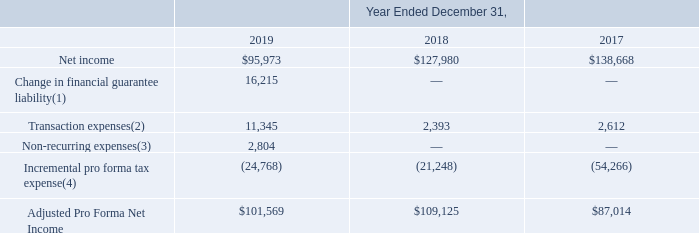ITEM 7. MANAGEMENT'S DISCUSSION AND ANALYSIS OF FINANCIAL CONDITION AND RESULTS OF OPERATIONS (United States Dollars in thousands, except per share data and unless otherwise indicated)
In light of the anticipated material non-cash charges to be recorded in connection with our financial guarantee arrangements as required subsequent to the adoption and implementation of ASU 2016-13 (as discussed in Note 1 to the Notes to Consolidated Financial Statements in Item 8 within "Accounting Standards Issued, But Not Yet Adopted – Measurement of credit losses on financial instruments"), management is evaluating both the disclosure of additional non-GAAP financial measures and the modification of its historical computation of adjusted EBITDA commencing in 2020 to enhance the disclosure of indicators of our business performance over the long term and to provide additional useful information to users of our financial statements.
Further, we utilize Adjusted Pro Forma Net Income, which we define as consolidated net income, adjusted for (i) transaction and non-recurring expenses; (ii) for 2019, losses associated with the financial guarantee arrangement for a Bank Partner that did not renew its loan origination agreement; and (iii) incremental pro forma tax expense assuming all of our noncontrolling interests were subject to income taxation. Adjusted Pro Forma Net Income is a useful measure because it makes our results more directly comparable to public companies that have the vast majority of their earnings subject to corporate income taxation. Adjusted Pro Forma Net Income has limitations as an analytical tool and should not be considered in isolation from, or as a substitute for, the analysis of other GAAP financial measures, such as net income. Some of the limitations of Adjusted Pro Forma Net Income include:
• It makes assumptions about tax expense, which may differ from actual results; and • It is not a universally consistent calculation, which limits its usefulness as a comparative measure.
Management compensates for the inherent limitations associated with using the measure of Adjusted Pro Forma Net Income through disclosure of such limitations, presentation of our financial statements in accordance with GAAP and reconciliation of Adjusted Pro Forma Net Income to the most directly comparable GAAP measure, net income, as presented below.
(1) Includes losses recorded in the fourth quarter of 2019 associated with the financial guarantee arrangement for a Bank Partner that did not renew its loan origination agreement when it expired in November 2019. See Note 14 to the Notes to Consolidated Financial Statements included in Item 8 for additional discussion of our financial guarantee arrangements.
(2) For the year ended December 31, 2019, includes loss on remeasurement of our tax receivable agreement liability of $9.8 million and professional fees associated with our strategic alternatives review process of $1.5 million. For the year ended December 31, 2018, includes certain costs associated with our IPO, which were not deferrable against the proceeds of the IPO. Further, includes certain costs, such as legal and debt arrangement costs, related to our March 2018 term loan upsizing. For the year ended December 31, 2017, includes one-time fees paid to an affiliate of one of the members of the board of managers in conjunction with the August 2017 term loan transaction.
(3) For the year ended December 31, 2019, includes (i) legal fees associated with IPO related litigation of $2.0 million, (ii) one-time tax compliance fees related to filing the final tax return for the Former Corporate Investors associated with the Reorganization Transactions of $0.2 million, and (iii) lien filing expenses related to certain Bank Partner solar loans of $0.6 million.
(4) Represents the incremental tax effect on net income, adjusted for the items noted above, assuming that all consolidated net income was subject to corporate taxation for the periods presented. For the years ended December 31, 2019, 2018 and 2017, we assumed effective tax rates of 14.8%, 19.7% and 38.4%, respectively.
Which years does the table provide? 2019, 2018, 2017. What was the Change in financial guarantee liability in 2019?
Answer scale should be: thousand. 16,215. What does Incremental pro forma tax expense represent? The incremental tax effect on net income, adjusted for the items noted above, assuming that all consolidated net income was subject to corporate taxation for the periods presented. How many years did Adjusted Pro Forma Net Income exceed $100,000 thousand? 2019##2018
Answer: 2. What was the change in net income between 2017 and 2018?
Answer scale should be: thousand. 127,980-138,668
Answer: -10688. What was the percentage change in Transaction expenses between 2018 and 2019?
Answer scale should be: percent. (11,345-2,393)/2,393
Answer: 374.09. 